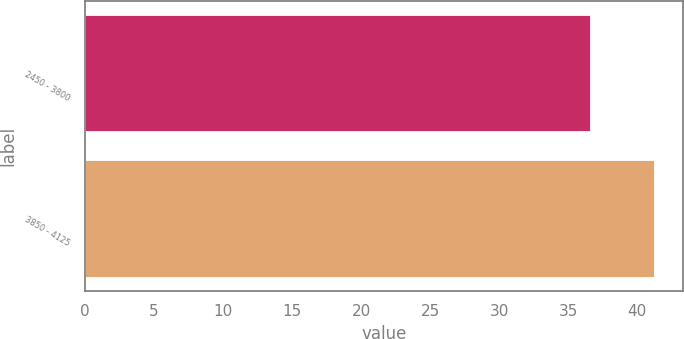Convert chart to OTSL. <chart><loc_0><loc_0><loc_500><loc_500><bar_chart><fcel>2450 - 3800<fcel>3850 - 4125<nl><fcel>36.6<fcel>41.23<nl></chart> 